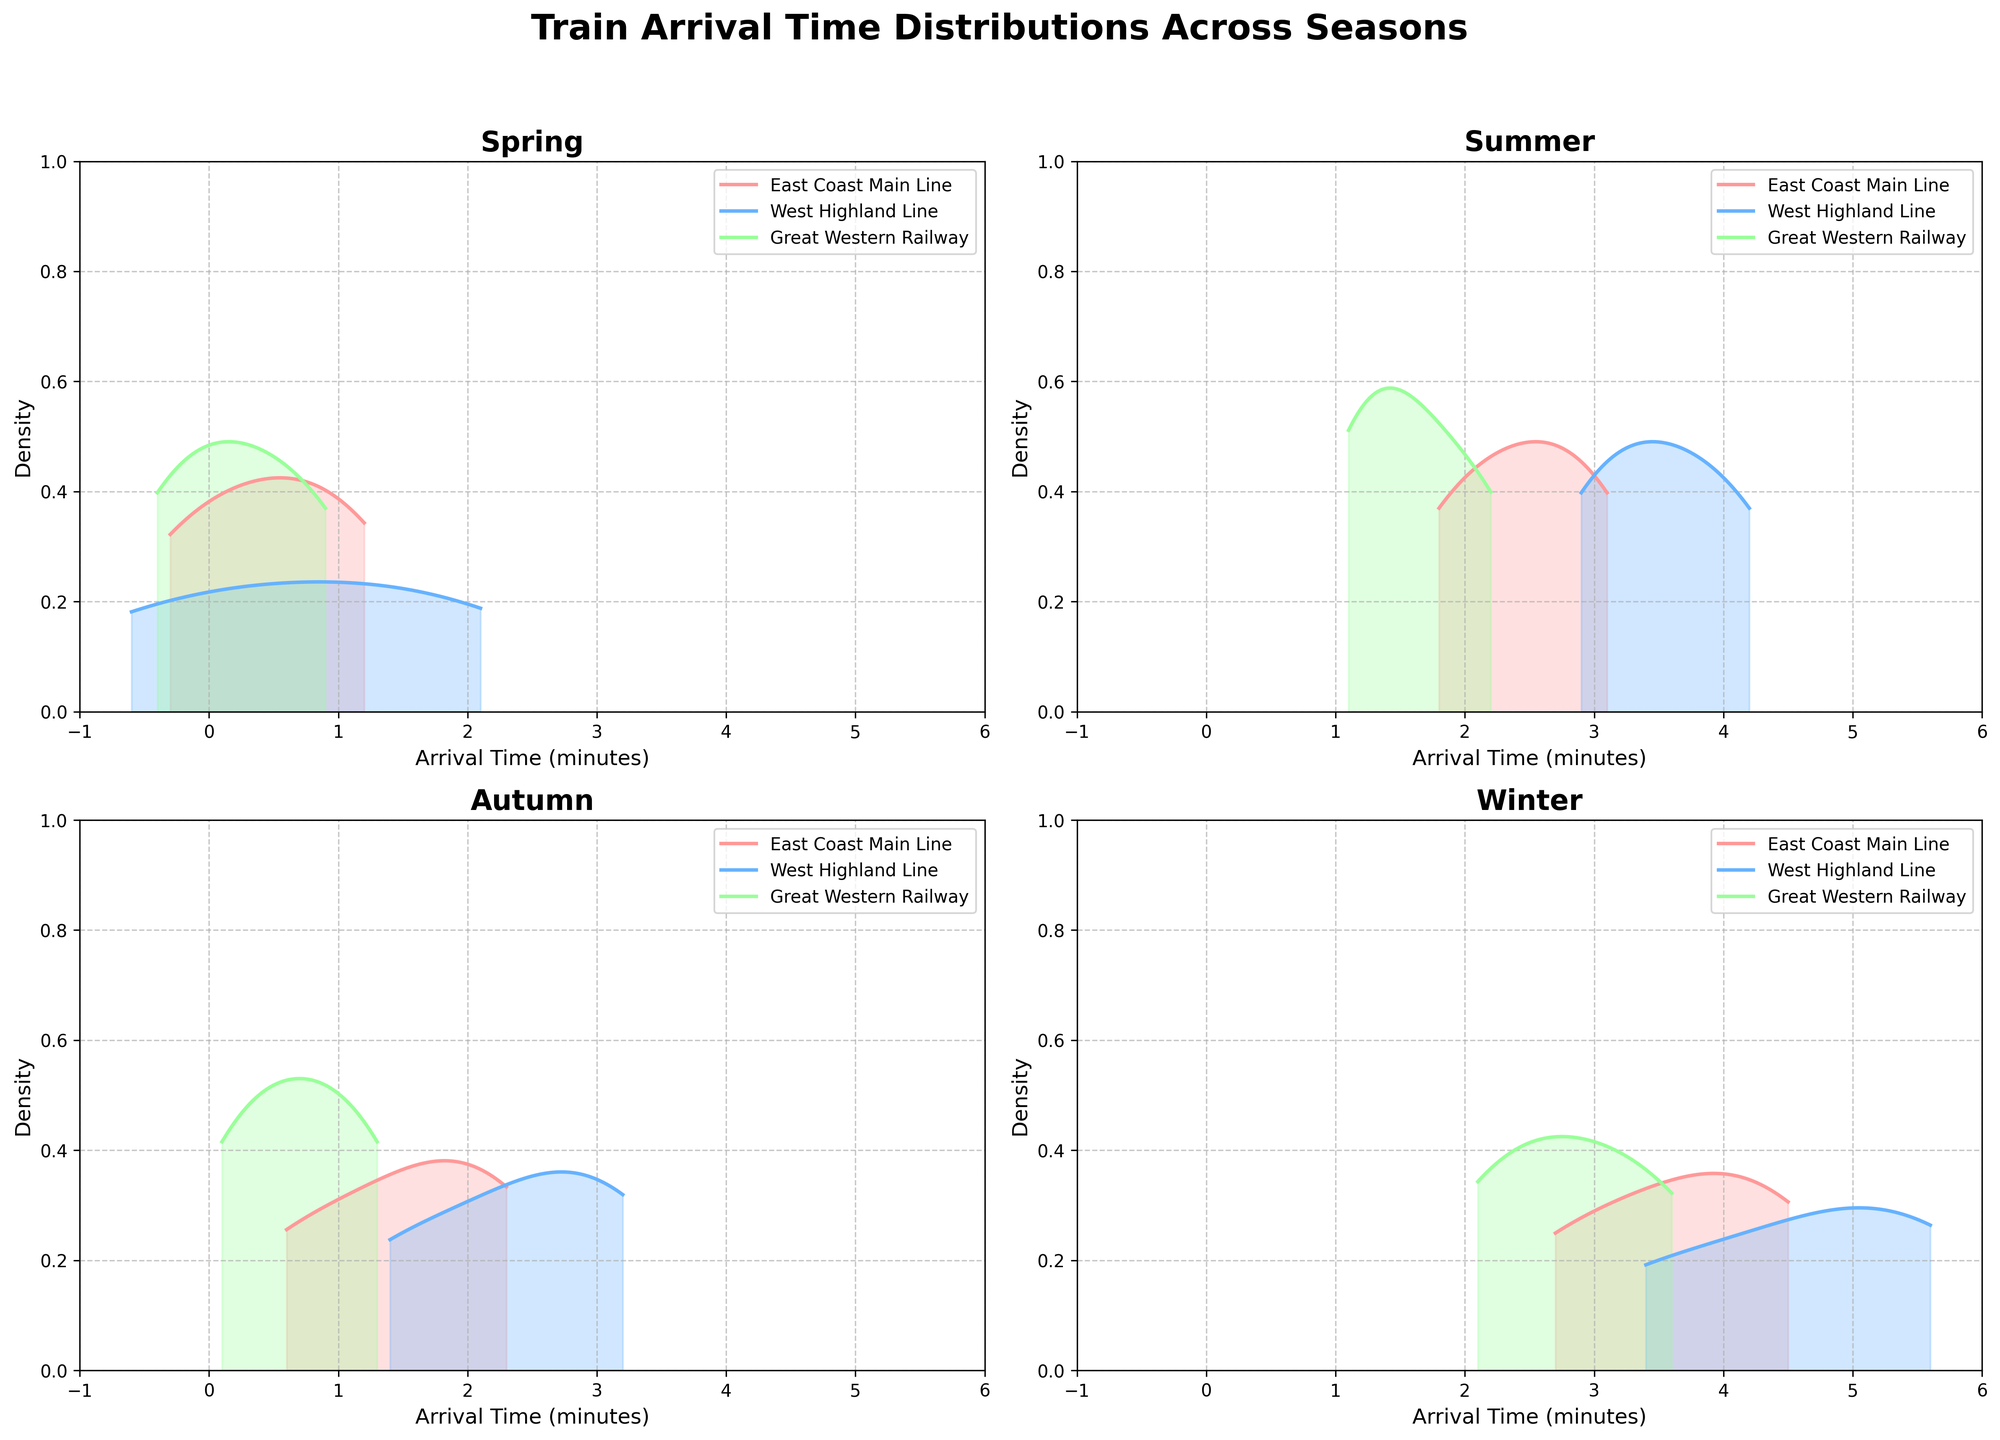What season has the highest peak density for the East Coast Main Line? From the plot, the East Coast Main Line density curve has the highest peak during Winter. The peak density is the highest point on the density curve, indicating the most common arrival time.
Answer: Winter How does the average arrival time for the West Highland Line in Summer compare to Autumn? The density curves for the West Highland Line in both Summer and Autumn have their peaks. The peak of Summer is around 3.5 - 4 minutes, while in Autumn, it is around 2 - 3 minutes. The average arrival time in Summer is higher.
Answer: Higher in Summer What can you infer about the spread of arrival times for Great Western Railway across seasons? Looking at the density plots, the width of the curves shows the spread of arrival times. For Great Western Railway, the spread is relatively narrow in Spring and wider in both Summer and Winter. Most spread is shown in Winter.
Answer: Most spread in Winter Which season has the most variable arrival times for the East Coast Main Line? From the plot, Winter shows the highest variation in arrival times for the East Coast Main Line, indicated by a wider spread of the density curve.
Answer: Winter What season has the shortest peak for the West Highland Line? The smallest peak for the West Highland Line is during Spring, indicating the lowest density of arrival times in that season.
Answer: Spring Compare the peak densities of Great Western Railway in Spring and Winter. Which season is higher? The peak density for Great Western Railway is higher in Spring than in Winter, as the curve reaches a higher point in Spring.
Answer: Spring Between Spring and Summer, which season's density plots indicate more consistent arrival times across all three train lines? In Spring, the density plots are narrower and more peaked for all three train lines, indicating more consistent arrival times compared to the broader and more variable density plots in Summer.
Answer: Spring 